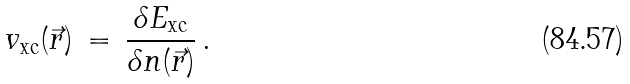Convert formula to latex. <formula><loc_0><loc_0><loc_500><loc_500>v _ { \text {xc} } ( \vec { r } ) \, = \, { \frac { \delta E _ { \text {xc} } } { \delta n ( \vec { r } ) } } \, .</formula> 